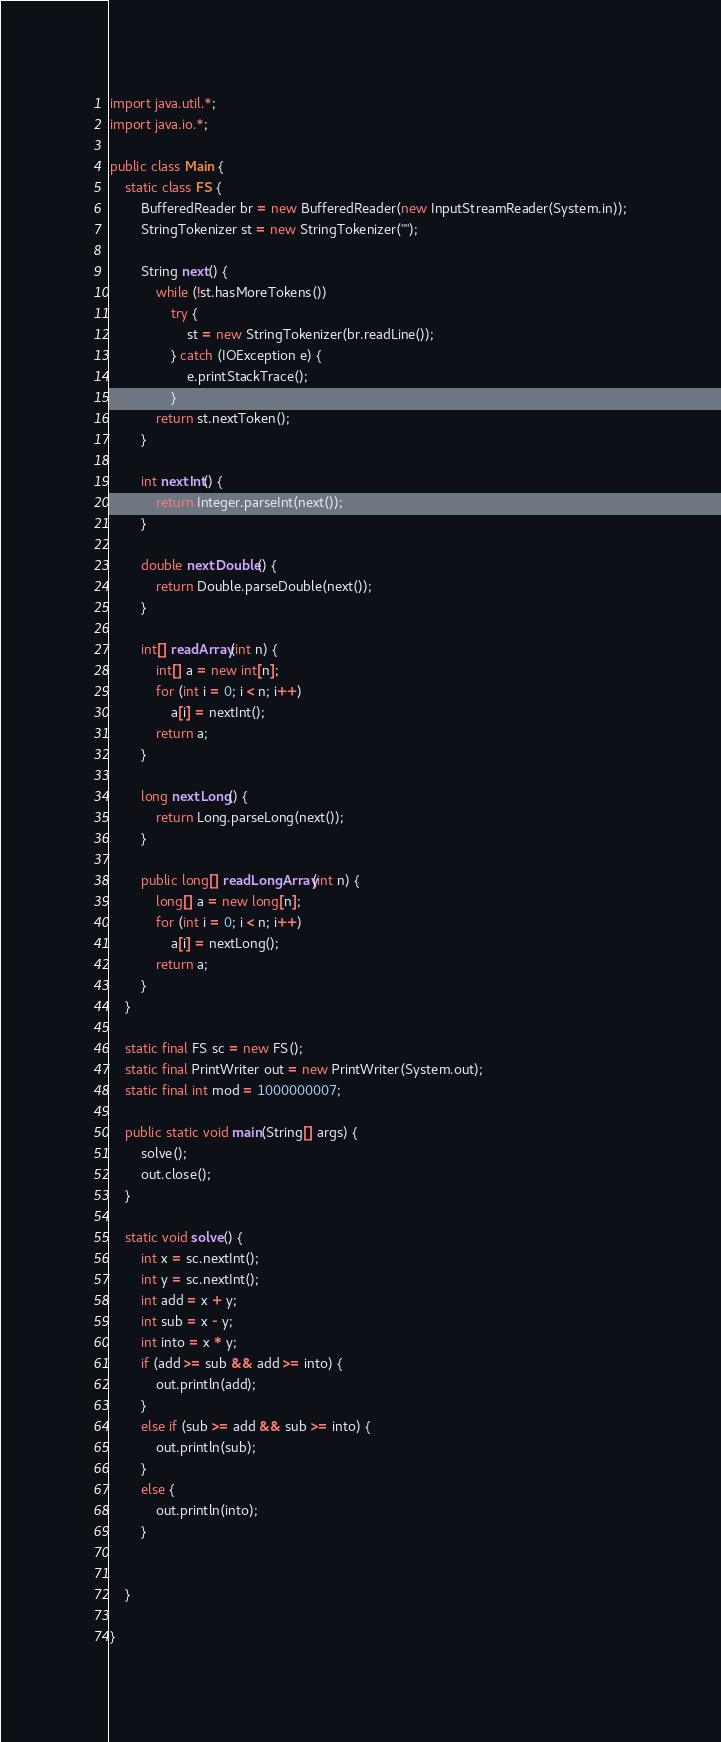<code> <loc_0><loc_0><loc_500><loc_500><_Java_>import java.util.*;
import java.io.*;

public class Main {
	static class FS {
		BufferedReader br = new BufferedReader(new InputStreamReader(System.in));
		StringTokenizer st = new StringTokenizer("");

		String next() {
			while (!st.hasMoreTokens())
				try {
					st = new StringTokenizer(br.readLine());
				} catch (IOException e) {
					e.printStackTrace();
				}
			return st.nextToken();
		}

		int nextInt() {
			return Integer.parseInt(next());
		}

		double nextDouble() {
			return Double.parseDouble(next());
		}

		int[] readArray(int n) {
			int[] a = new int[n];
			for (int i = 0; i < n; i++)
				a[i] = nextInt();
			return a;
		}

		long nextLong() {
			return Long.parseLong(next());
		}

		public long[] readLongArray(int n) {
			long[] a = new long[n];
			for (int i = 0; i < n; i++)
				a[i] = nextLong();
			return a;
		}
	}

	static final FS sc = new FS();
	static final PrintWriter out = new PrintWriter(System.out);
	static final int mod = 1000000007;

	public static void main(String[] args) {
		solve();
		out.close();
	}

	static void solve() {
		int x = sc.nextInt();
		int y = sc.nextInt();
		int add = x + y;
		int sub = x - y;
		int into = x * y;
		if (add >= sub && add >= into) {
			out.println(add);
		}
		else if (sub >= add && sub >= into) {
			out.println(sub);
		}
		else {
			out.println(into);
		}
		

	}

}
</code> 